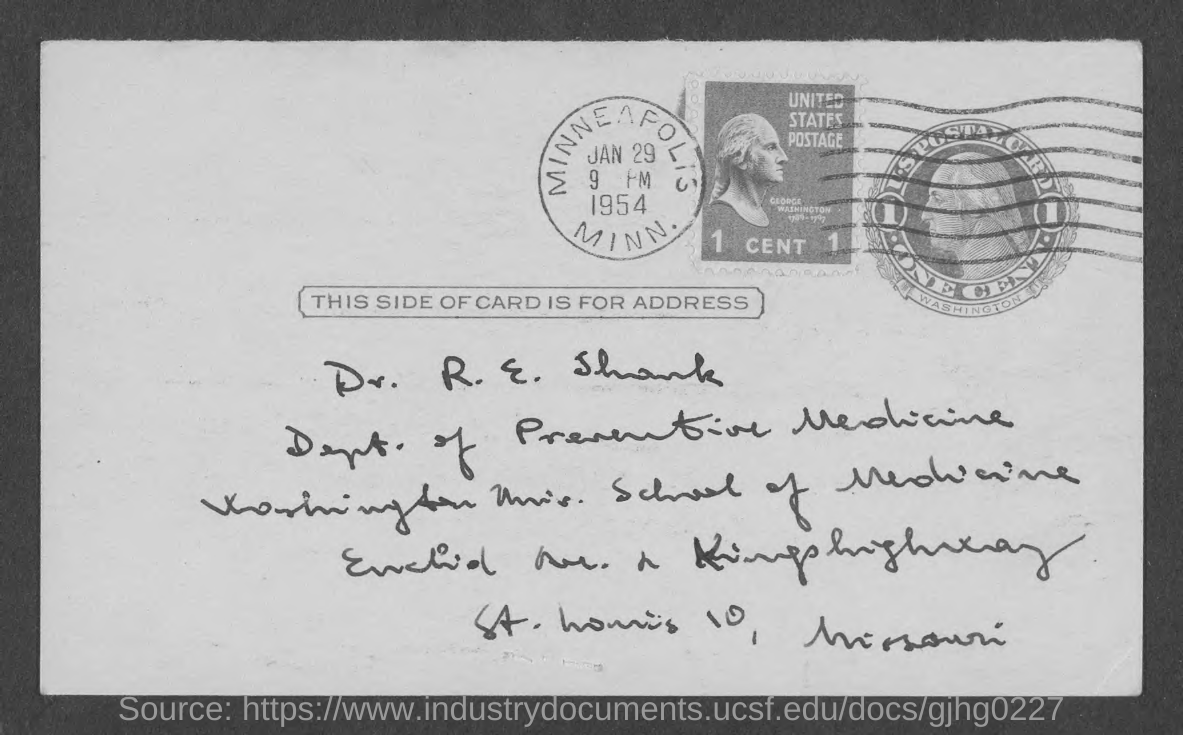To whom is the card addressed?
Keep it short and to the point. Dr. R. E. Shank. Which department is Dr. R. E. Shank part of?
Offer a terse response. Dept. of Preventive Medicine. Which is the place mentioned on the stamp?
Your response must be concise. MINNEAPOLIS. 